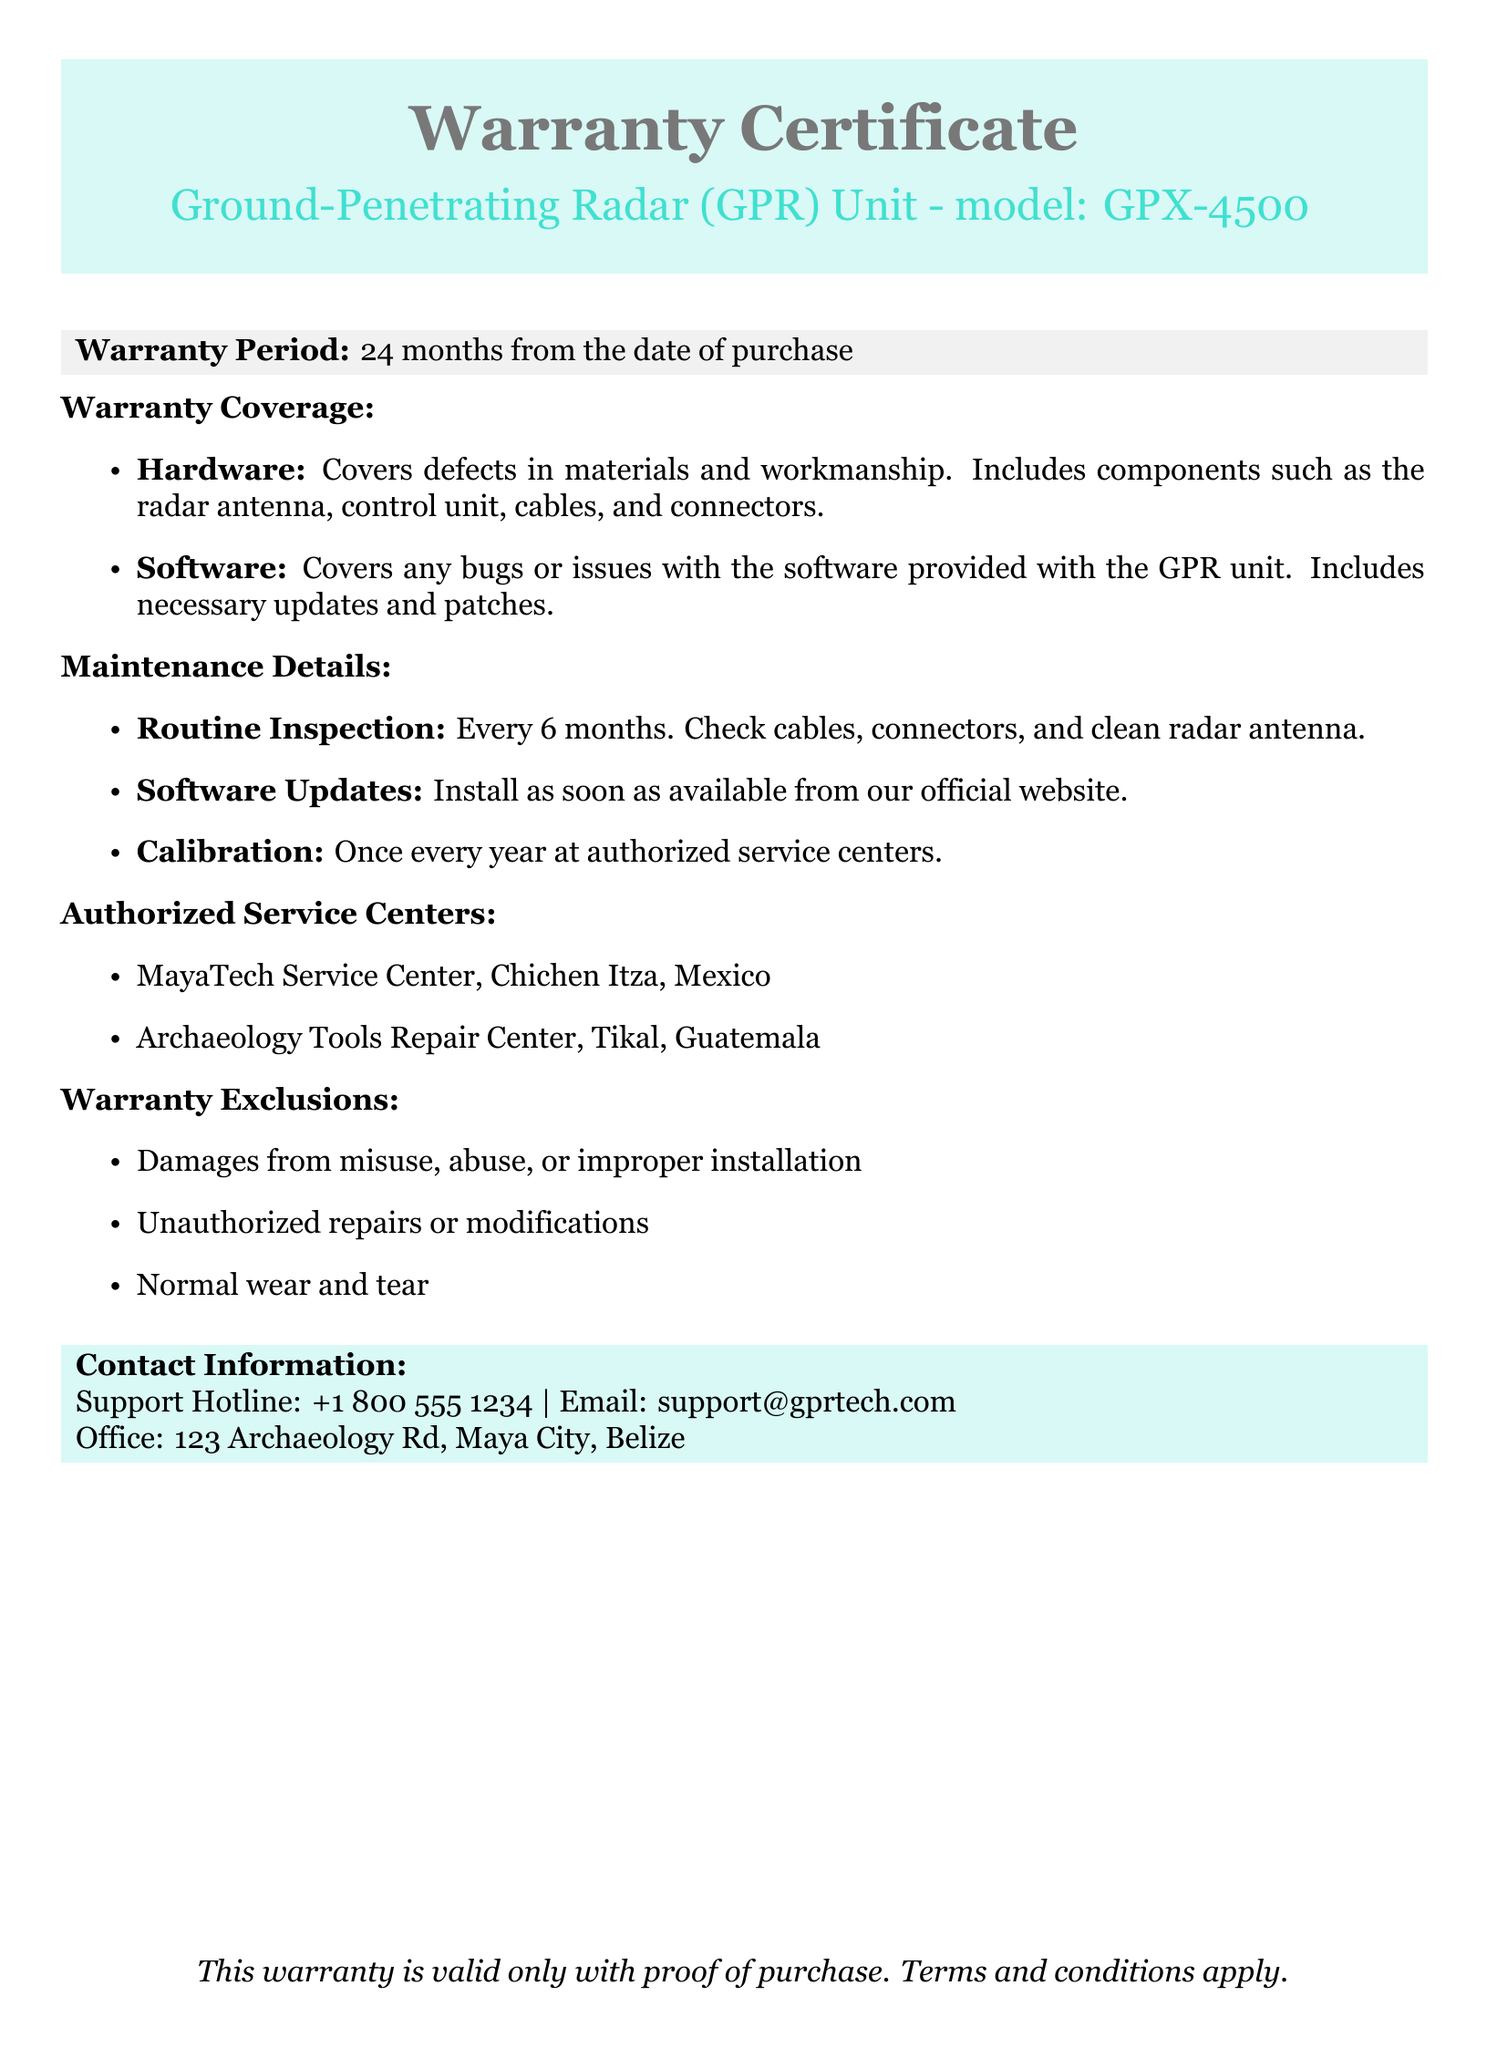What is the warranty period? The warranty period is stated clearly in the document as being 24 months from the date of purchase.
Answer: 24 months What components are covered under hardware? The hardware coverage includes specific components like the radar antenna, control unit, cables, and connectors as mentioned in the document.
Answer: Radar antenna, control unit, cables, connectors When should routine inspections be performed? The document states that routine inspections should be conducted every 6 months, providing a clear timeframe for maintenance.
Answer: Every 6 months Which centers are authorized for service? The document lists the authorized service centers, including names and locations. The centers mentioned are MayaTech Service Center and Archaeology Tools Repair Center.
Answer: MayaTech Service Center, Archaeology Tools Repair Center What is excluded from the warranty coverage? The document enumerates multiple exclusions from the warranty coverage such as damages from misuse and normal wear and tear, highlighting important limitations.
Answer: Damages from misuse, abuse, or improper installation How often is calibration required? The document specifies that calibration should occur once every year at authorized service centers, a critical maintenance requirement for ensuring the tool’s functionality.
Answer: Once every year What must be provided for the warranty to be valid? The warranty document states explicitly that proof of purchase is necessary for the warranty to remain valid.
Answer: Proof of purchase What type of software issues are covered? The document indicates that issues regarding bugs or problems with the software provided with the GPR unit are included under warranty coverage.
Answer: Bugs or issues with the software What is the support hotline number? The document provides a support hotline number for assistance, which is vital contact information for users in need of help.
Answer: +1 800 555 1234 